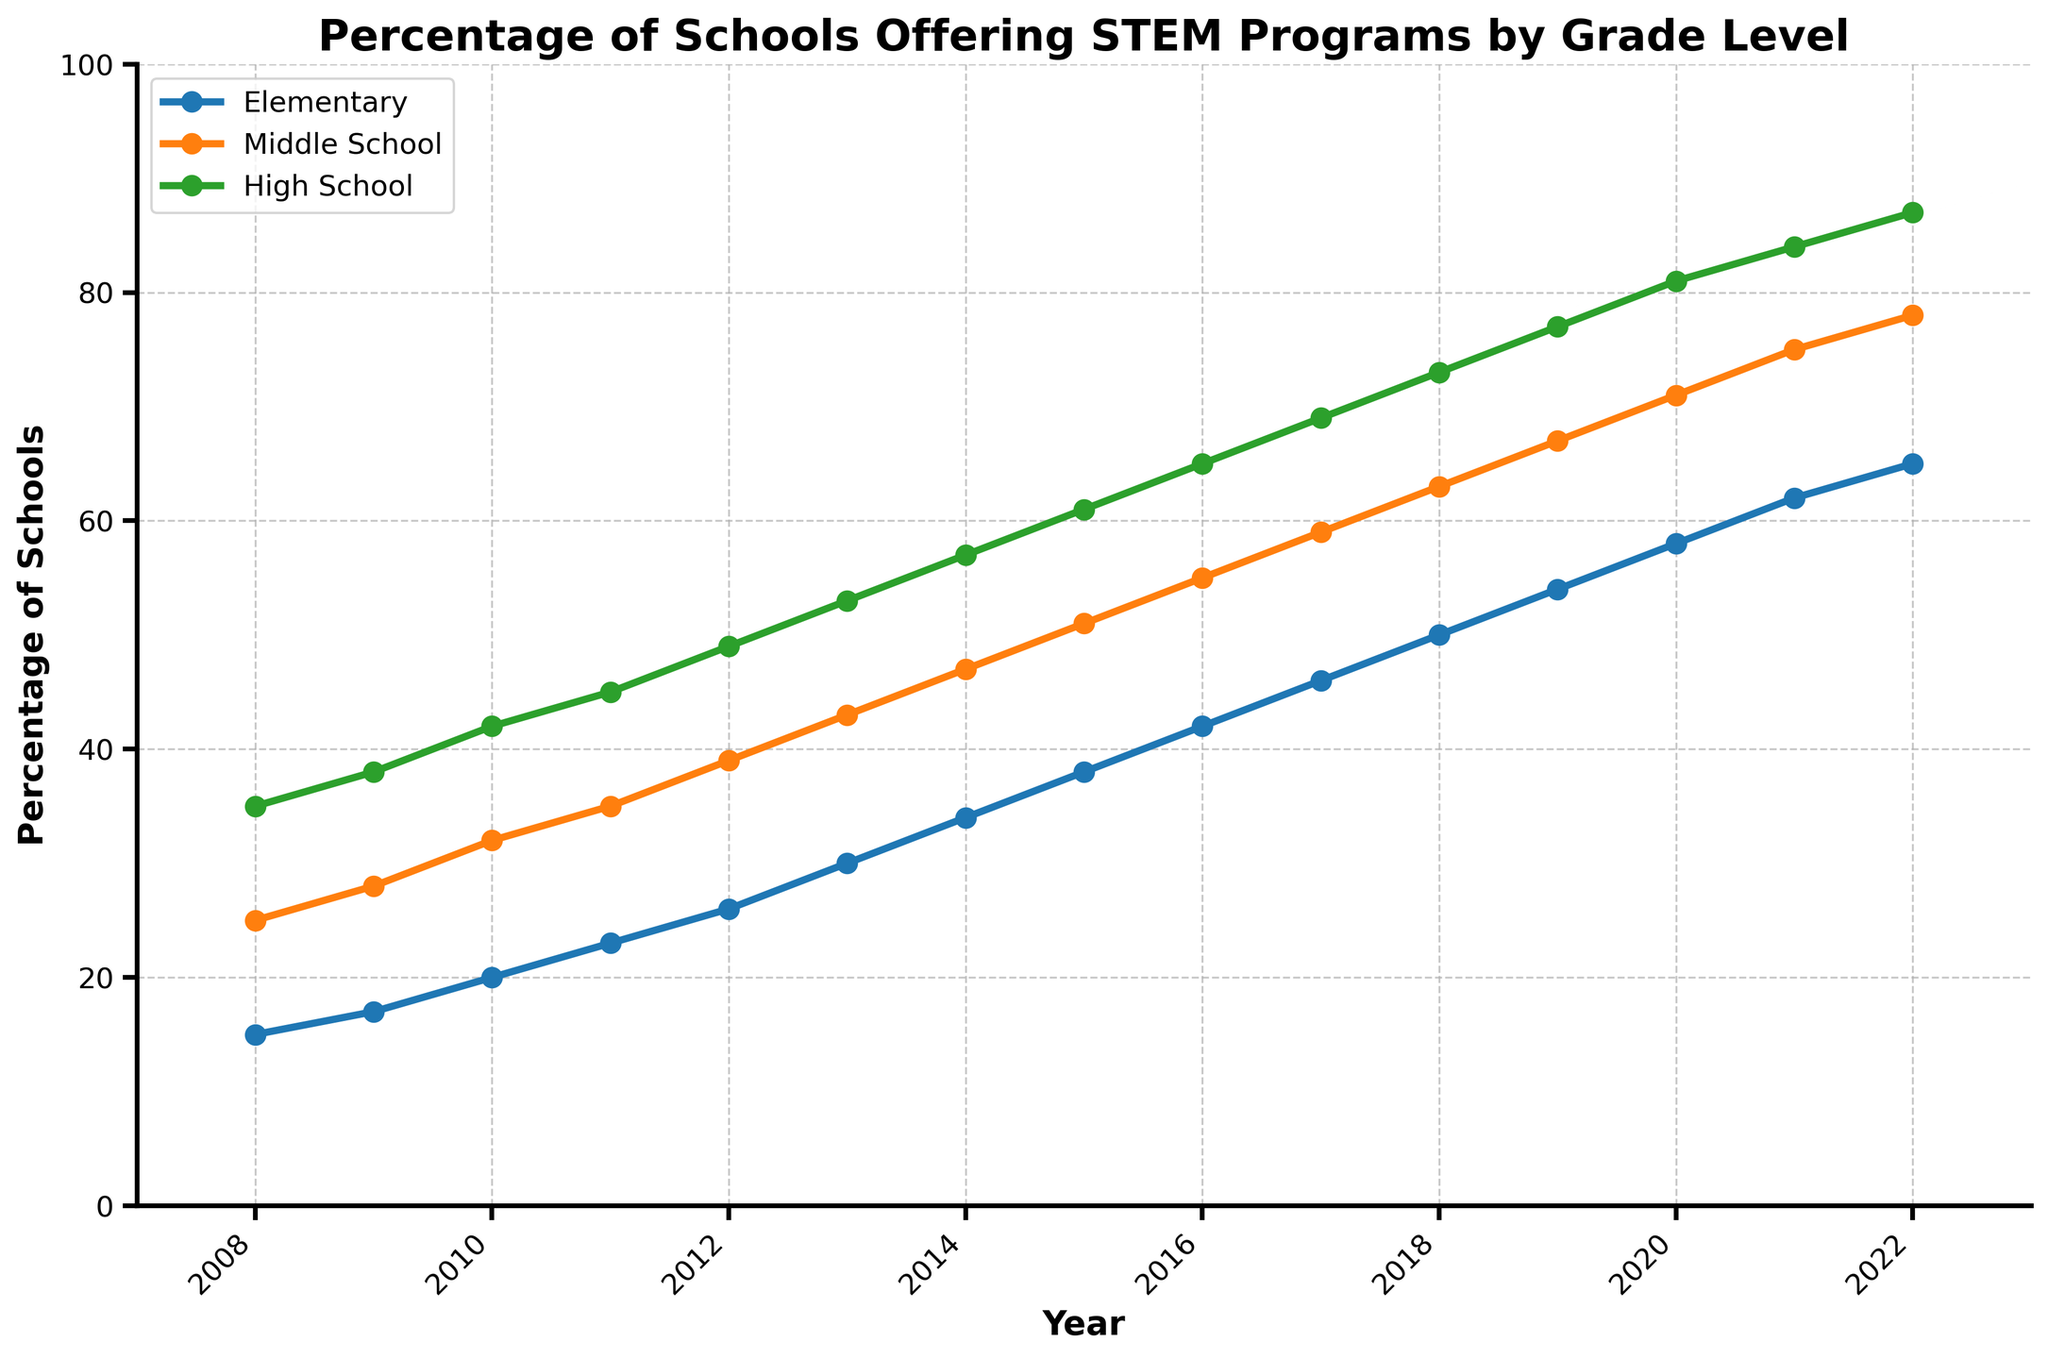How does the percentage of schools offering STEM programs in Elementary compare to Middle School in 2022? Look at the endpoints of the lines for Elementary and Middle School in 2022. Elementary is at 65% and Middle School is at 78%. 65% is less than 78%
Answer: Elementary offers 13% less than Middle School In what year did the percentage of High Schools offering STEM programs reach 50%? Locate the High School line and identify the year at which it crosses the 50% mark. This happened between 2012 and 2013, specifically in 2013
Answer: 2013 By how much did the percentage of Elementary schools offering STEM programs increase from 2015 to 2018? Identify the values for Elementary in 2015 and 2018. The values are 38% and 50%, respectively. Calculate the difference: 50 - 38 = 12
Answer: 12% What is the average percentage of Middle Schools offering STEM programs over the 15 years? Sum the values for Middle School across all years and divide by the number of years (15): (25 + 28 + 32 + 35 + 39 + 43 + 47 + 51 + 55 + 59 + 63 + 67 + 71 + 75 + 78) / 15 = 845 / 15 = 56.33
Answer: 56.33% Compare the growth trends of Elementary and High School STEM offerings. Which one grew faster, and by how much in the first 5 years? Calculate the growth from 2008 to 2013 for both levels:
Elementary: 30 - 15 = 15
High School: 53 - 35 = 18
Compare the growth: 18 - 15 = 3
Answer: High School; 3% What is the difference in the percentage of Middle Schools and High Schools offering STEM programs in 2020? Middle School in 2020 is at 71%, and High School is at 81%. Calculate the difference: 81 - 71 = 10
Answer: 10% Which year shows the most significant jump in percentage for Elementary schools? Examine the increments year by year for Elementary schools and identify the year with the largest increase. The largest jump occurs from 2011 to 2012: 26 - 23 = 3%
Answer: 2012 By what percentage did Middle School offerings exceed Elementary offerings in 2016? Middle School percentage in 2016 is 55% and Elementary is 42%. Calculate the difference: 55 - 42 = 13
Answer: 13% 